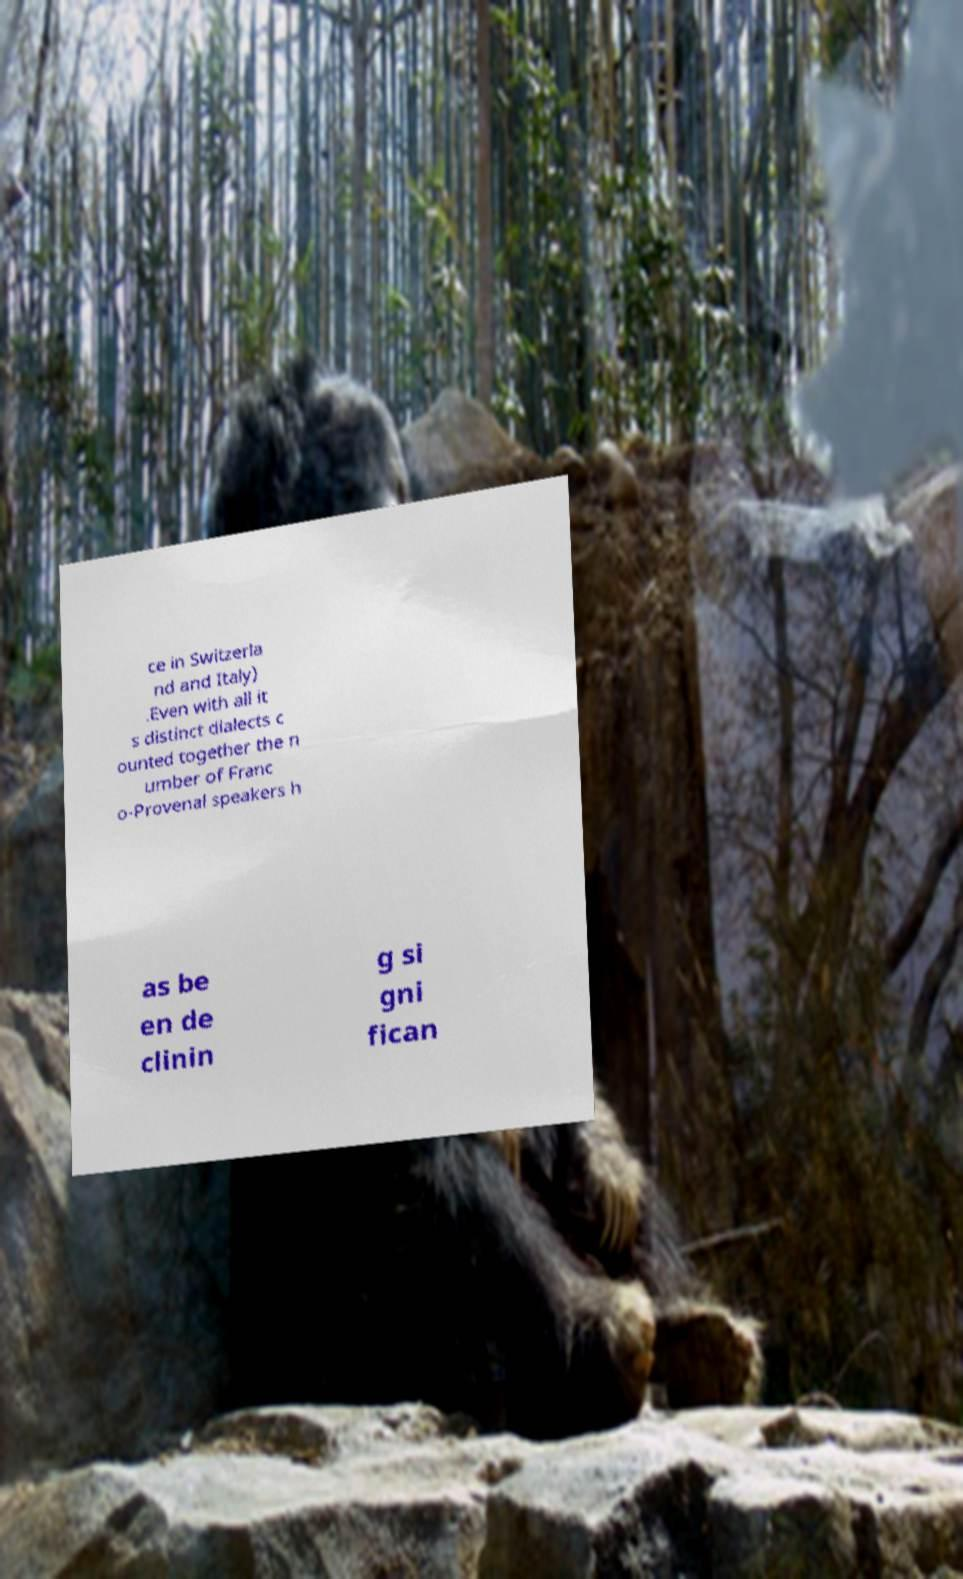Please read and relay the text visible in this image. What does it say? ce in Switzerla nd and Italy) .Even with all it s distinct dialects c ounted together the n umber of Franc o-Provenal speakers h as be en de clinin g si gni fican 